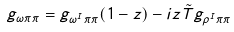Convert formula to latex. <formula><loc_0><loc_0><loc_500><loc_500>g _ { \omega \pi \pi } = g _ { \omega ^ { I } \pi \pi } ( 1 - z ) - i z \tilde { T } g _ { \rho ^ { I } \pi \pi }</formula> 